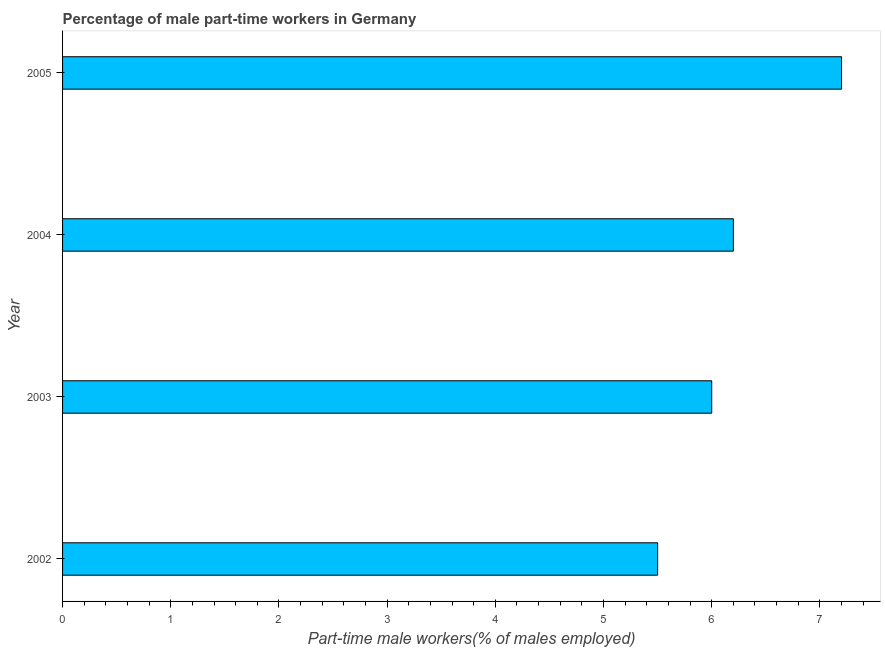Does the graph contain grids?
Offer a terse response. No. What is the title of the graph?
Provide a short and direct response. Percentage of male part-time workers in Germany. What is the label or title of the X-axis?
Your response must be concise. Part-time male workers(% of males employed). What is the label or title of the Y-axis?
Your response must be concise. Year. What is the percentage of part-time male workers in 2004?
Ensure brevity in your answer.  6.2. Across all years, what is the maximum percentage of part-time male workers?
Your answer should be very brief. 7.2. Across all years, what is the minimum percentage of part-time male workers?
Keep it short and to the point. 5.5. In which year was the percentage of part-time male workers maximum?
Give a very brief answer. 2005. In which year was the percentage of part-time male workers minimum?
Make the answer very short. 2002. What is the sum of the percentage of part-time male workers?
Ensure brevity in your answer.  24.9. What is the average percentage of part-time male workers per year?
Keep it short and to the point. 6.22. What is the median percentage of part-time male workers?
Give a very brief answer. 6.1. What is the ratio of the percentage of part-time male workers in 2002 to that in 2004?
Offer a terse response. 0.89. Is the sum of the percentage of part-time male workers in 2003 and 2004 greater than the maximum percentage of part-time male workers across all years?
Keep it short and to the point. Yes. What is the difference between two consecutive major ticks on the X-axis?
Ensure brevity in your answer.  1. What is the Part-time male workers(% of males employed) in 2004?
Provide a short and direct response. 6.2. What is the Part-time male workers(% of males employed) of 2005?
Your response must be concise. 7.2. What is the difference between the Part-time male workers(% of males employed) in 2002 and 2003?
Offer a terse response. -0.5. What is the difference between the Part-time male workers(% of males employed) in 2002 and 2004?
Your answer should be very brief. -0.7. What is the difference between the Part-time male workers(% of males employed) in 2003 and 2004?
Your answer should be very brief. -0.2. What is the difference between the Part-time male workers(% of males employed) in 2004 and 2005?
Give a very brief answer. -1. What is the ratio of the Part-time male workers(% of males employed) in 2002 to that in 2003?
Provide a short and direct response. 0.92. What is the ratio of the Part-time male workers(% of males employed) in 2002 to that in 2004?
Your answer should be very brief. 0.89. What is the ratio of the Part-time male workers(% of males employed) in 2002 to that in 2005?
Keep it short and to the point. 0.76. What is the ratio of the Part-time male workers(% of males employed) in 2003 to that in 2005?
Offer a terse response. 0.83. What is the ratio of the Part-time male workers(% of males employed) in 2004 to that in 2005?
Provide a short and direct response. 0.86. 